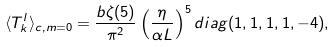Convert formula to latex. <formula><loc_0><loc_0><loc_500><loc_500>\langle T _ { k } ^ { l } \rangle _ { c , m = 0 } = \frac { b \zeta ( 5 ) } { \pi ^ { 2 } } \left ( \frac { \eta } { \alpha L } \right ) ^ { 5 } d i a g ( 1 , 1 , 1 , 1 , - 4 ) ,</formula> 